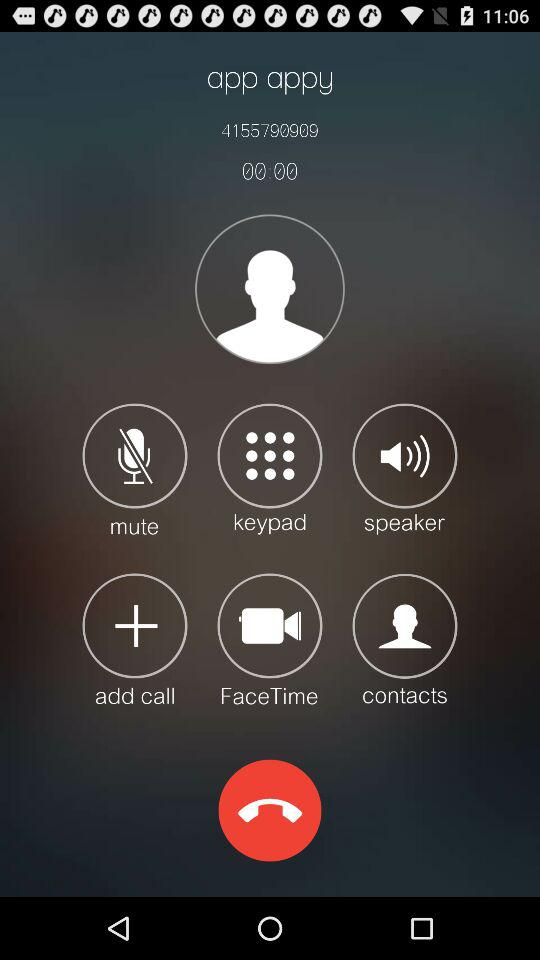By what name has the contact number been saved? The contact number has been saved as "app appy". 